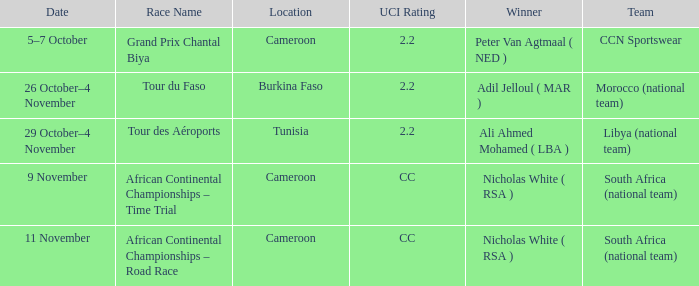Where will the race be held on november 11th? Cameroon. 